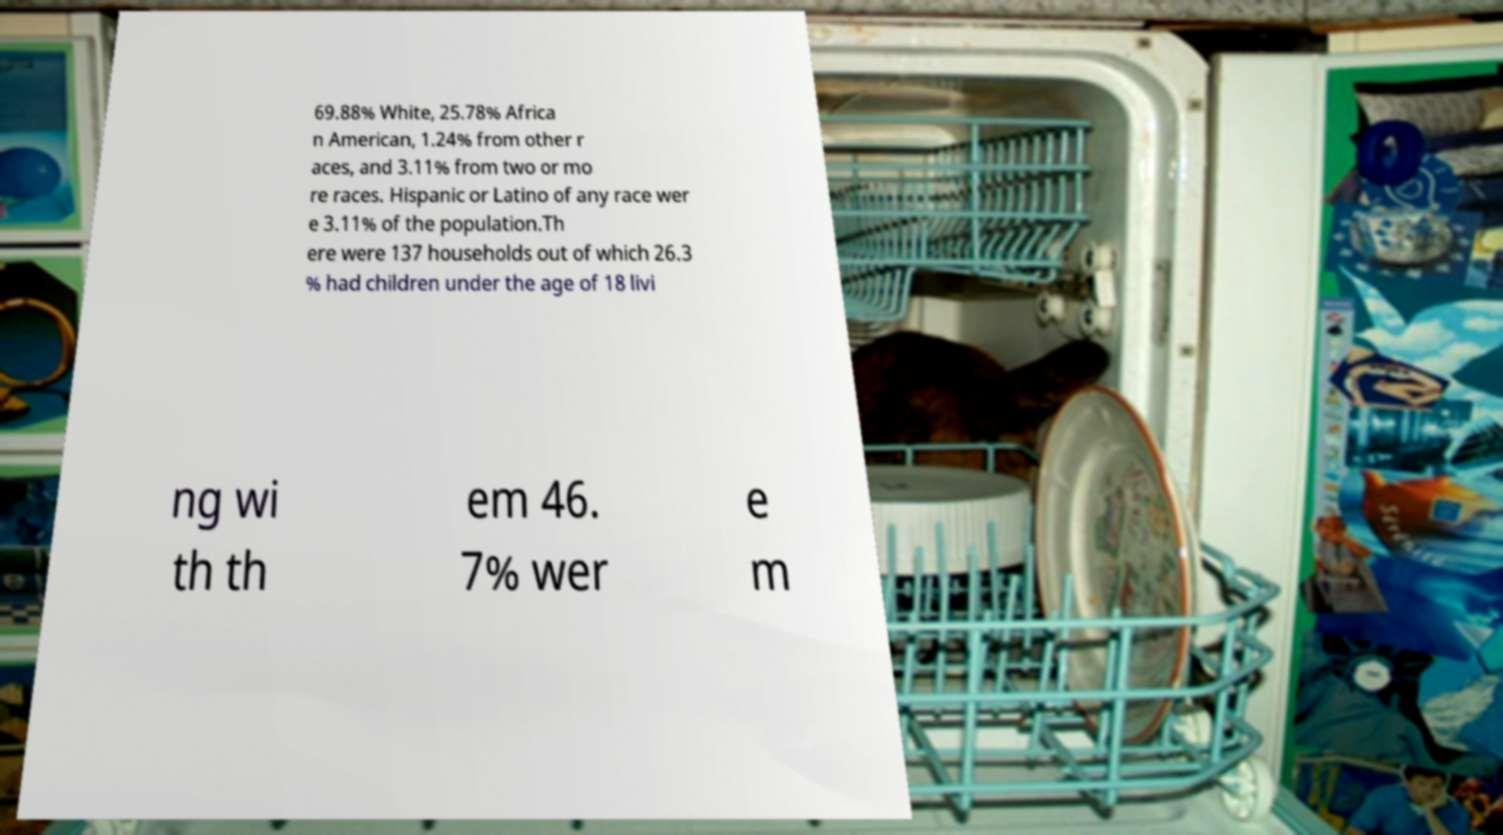There's text embedded in this image that I need extracted. Can you transcribe it verbatim? 69.88% White, 25.78% Africa n American, 1.24% from other r aces, and 3.11% from two or mo re races. Hispanic or Latino of any race wer e 3.11% of the population.Th ere were 137 households out of which 26.3 % had children under the age of 18 livi ng wi th th em 46. 7% wer e m 